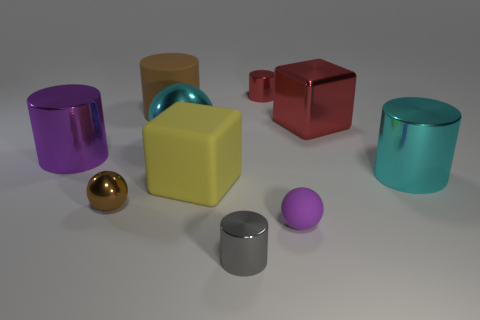There is a small shiny object that is the same color as the large metallic cube; what is its shape?
Your response must be concise. Cylinder. What size is the gray thing that is made of the same material as the purple cylinder?
Offer a very short reply. Small. There is a big cyan thing on the left side of the gray metal cylinder; what is its shape?
Provide a succinct answer. Sphere. Does the cube that is to the right of the big yellow thing have the same color as the small cylinder right of the tiny gray metallic object?
Provide a succinct answer. Yes. There is a cylinder that is the same color as the large shiny cube; what size is it?
Make the answer very short. Small. Are there any red rubber objects?
Keep it short and to the point. No. The metal thing that is to the left of the small object to the left of the tiny shiny cylinder that is in front of the large yellow thing is what shape?
Offer a very short reply. Cylinder. There is a small red shiny cylinder; what number of small gray objects are to the right of it?
Make the answer very short. 0. Do the tiny thing behind the large purple cylinder and the brown cylinder have the same material?
Your answer should be compact. No. How many other objects are the same shape as the tiny red shiny object?
Offer a very short reply. 4. 